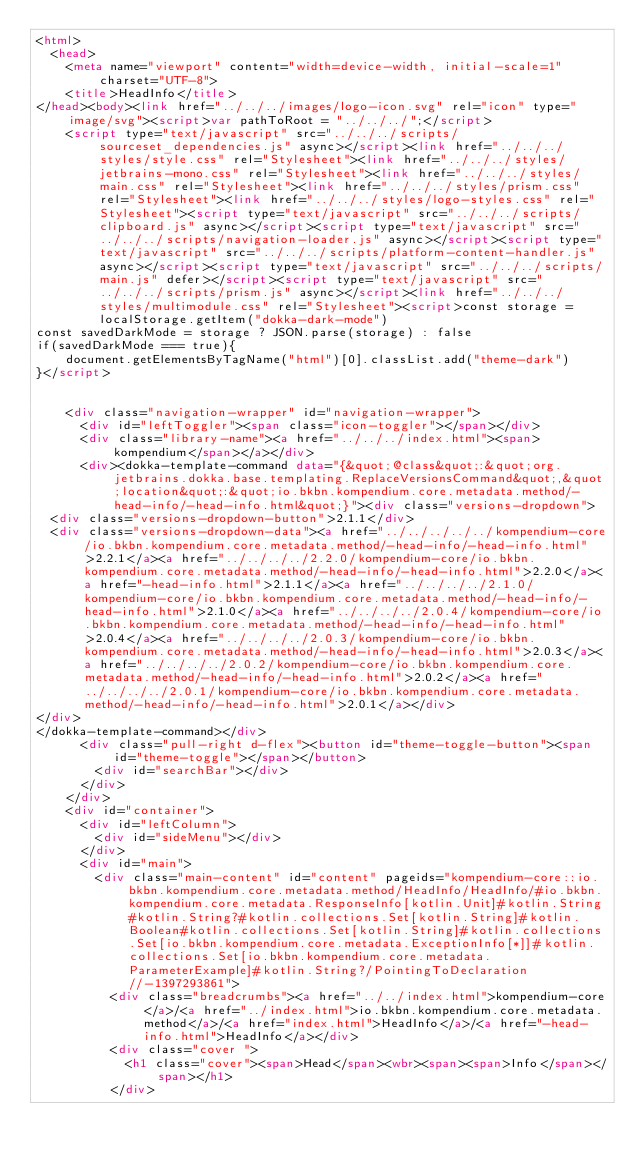<code> <loc_0><loc_0><loc_500><loc_500><_HTML_><html>
  <head>
    <meta name="viewport" content="width=device-width, initial-scale=1" charset="UTF-8">
    <title>HeadInfo</title>
</head><body><link href="../../../images/logo-icon.svg" rel="icon" type="image/svg"><script>var pathToRoot = "../../../";</script>
    <script type="text/javascript" src="../../../scripts/sourceset_dependencies.js" async></script><link href="../../../styles/style.css" rel="Stylesheet"><link href="../../../styles/jetbrains-mono.css" rel="Stylesheet"><link href="../../../styles/main.css" rel="Stylesheet"><link href="../../../styles/prism.css" rel="Stylesheet"><link href="../../../styles/logo-styles.css" rel="Stylesheet"><script type="text/javascript" src="../../../scripts/clipboard.js" async></script><script type="text/javascript" src="../../../scripts/navigation-loader.js" async></script><script type="text/javascript" src="../../../scripts/platform-content-handler.js" async></script><script type="text/javascript" src="../../../scripts/main.js" defer></script><script type="text/javascript" src="../../../scripts/prism.js" async></script><link href="../../../styles/multimodule.css" rel="Stylesheet"><script>const storage = localStorage.getItem("dokka-dark-mode")
const savedDarkMode = storage ? JSON.parse(storage) : false
if(savedDarkMode === true){
    document.getElementsByTagName("html")[0].classList.add("theme-dark")
}</script>

  
    <div class="navigation-wrapper" id="navigation-wrapper">
      <div id="leftToggler"><span class="icon-toggler"></span></div>
      <div class="library-name"><a href="../../../index.html"><span>kompendium</span></a></div>
      <div><dokka-template-command data="{&quot;@class&quot;:&quot;org.jetbrains.dokka.base.templating.ReplaceVersionsCommand&quot;,&quot;location&quot;:&quot;io.bkbn.kompendium.core.metadata.method/-head-info/-head-info.html&quot;}"><div class="versions-dropdown">
  <div class="versions-dropdown-button">2.1.1</div>
  <div class="versions-dropdown-data"><a href="../../../../../kompendium-core/io.bkbn.kompendium.core.metadata.method/-head-info/-head-info.html">2.2.1</a><a href="../../../../2.2.0/kompendium-core/io.bkbn.kompendium.core.metadata.method/-head-info/-head-info.html">2.2.0</a><a href="-head-info.html">2.1.1</a><a href="../../../../2.1.0/kompendium-core/io.bkbn.kompendium.core.metadata.method/-head-info/-head-info.html">2.1.0</a><a href="../../../../2.0.4/kompendium-core/io.bkbn.kompendium.core.metadata.method/-head-info/-head-info.html">2.0.4</a><a href="../../../../2.0.3/kompendium-core/io.bkbn.kompendium.core.metadata.method/-head-info/-head-info.html">2.0.3</a><a href="../../../../2.0.2/kompendium-core/io.bkbn.kompendium.core.metadata.method/-head-info/-head-info.html">2.0.2</a><a href="../../../../2.0.1/kompendium-core/io.bkbn.kompendium.core.metadata.method/-head-info/-head-info.html">2.0.1</a></div>
</div>
</dokka-template-command></div>
      <div class="pull-right d-flex"><button id="theme-toggle-button"><span id="theme-toggle"></span></button>
        <div id="searchBar"></div>
      </div>
    </div>
    <div id="container">
      <div id="leftColumn">
        <div id="sideMenu"></div>
      </div>
      <div id="main">
        <div class="main-content" id="content" pageids="kompendium-core::io.bkbn.kompendium.core.metadata.method/HeadInfo/HeadInfo/#io.bkbn.kompendium.core.metadata.ResponseInfo[kotlin.Unit]#kotlin.String#kotlin.String?#kotlin.collections.Set[kotlin.String]#kotlin.Boolean#kotlin.collections.Set[kotlin.String]#kotlin.collections.Set[io.bkbn.kompendium.core.metadata.ExceptionInfo[*]]#kotlin.collections.Set[io.bkbn.kompendium.core.metadata.ParameterExample]#kotlin.String?/PointingToDeclaration//-1397293861">
          <div class="breadcrumbs"><a href="../../index.html">kompendium-core</a>/<a href="../index.html">io.bkbn.kompendium.core.metadata.method</a>/<a href="index.html">HeadInfo</a>/<a href="-head-info.html">HeadInfo</a></div>
          <div class="cover ">
            <h1 class="cover"><span>Head</span><wbr><span><span>Info</span></span></h1>
          </div></code> 